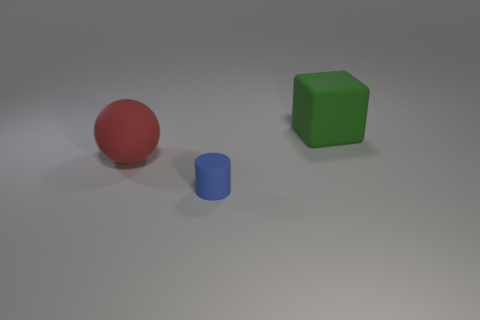What size is the thing that is both on the right side of the red matte thing and behind the tiny blue rubber cylinder?
Provide a short and direct response. Large. What is the color of the thing that is behind the tiny rubber thing and left of the green block?
Keep it short and to the point. Red. Is the number of large red objects on the right side of the matte cylinder less than the number of blue objects behind the large block?
Keep it short and to the point. No. What number of tiny blue things have the same shape as the large red matte object?
Your answer should be very brief. 0. There is a red sphere that is made of the same material as the big green cube; what is its size?
Your answer should be compact. Large. There is a matte object that is in front of the large matte object to the left of the big rubber block; what is its color?
Provide a succinct answer. Blue. There is a small blue object; is its shape the same as the large object that is in front of the large green matte block?
Give a very brief answer. No. Are there the same number of small matte cubes and green blocks?
Make the answer very short. No. What number of purple matte balls have the same size as the red ball?
Give a very brief answer. 0. Do the big rubber sphere that is left of the small cylinder and the big matte object to the right of the rubber cylinder have the same color?
Provide a succinct answer. No. 